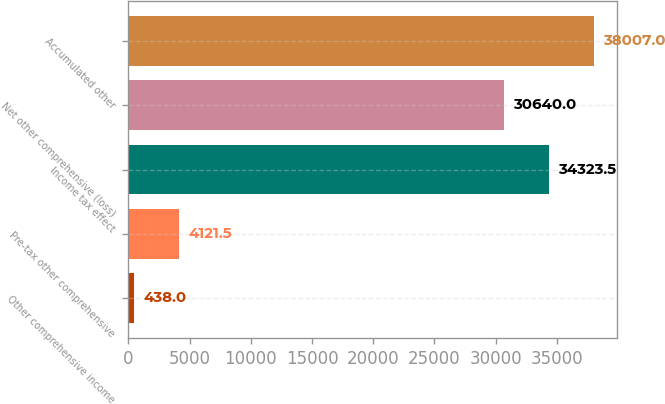Convert chart. <chart><loc_0><loc_0><loc_500><loc_500><bar_chart><fcel>Other comprehensive income<fcel>Pre-tax other comprehensive<fcel>Income tax effect<fcel>Net other comprehensive (loss)<fcel>Accumulated other<nl><fcel>438<fcel>4121.5<fcel>34323.5<fcel>30640<fcel>38007<nl></chart> 